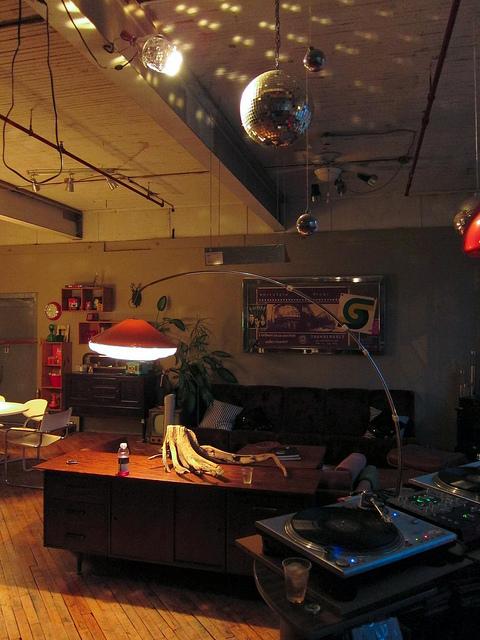Is there any fruit in the room?
Keep it brief. No. What is big and red in the room?
Short answer required. Lamp. Is there going to be a party?
Answer briefly. Yes. 